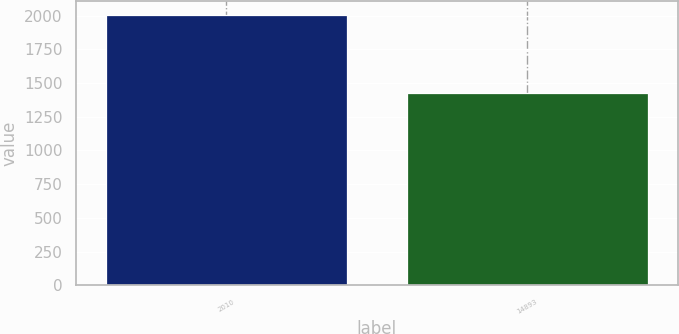Convert chart. <chart><loc_0><loc_0><loc_500><loc_500><bar_chart><fcel>2010<fcel>14893<nl><fcel>2007<fcel>1423.1<nl></chart> 